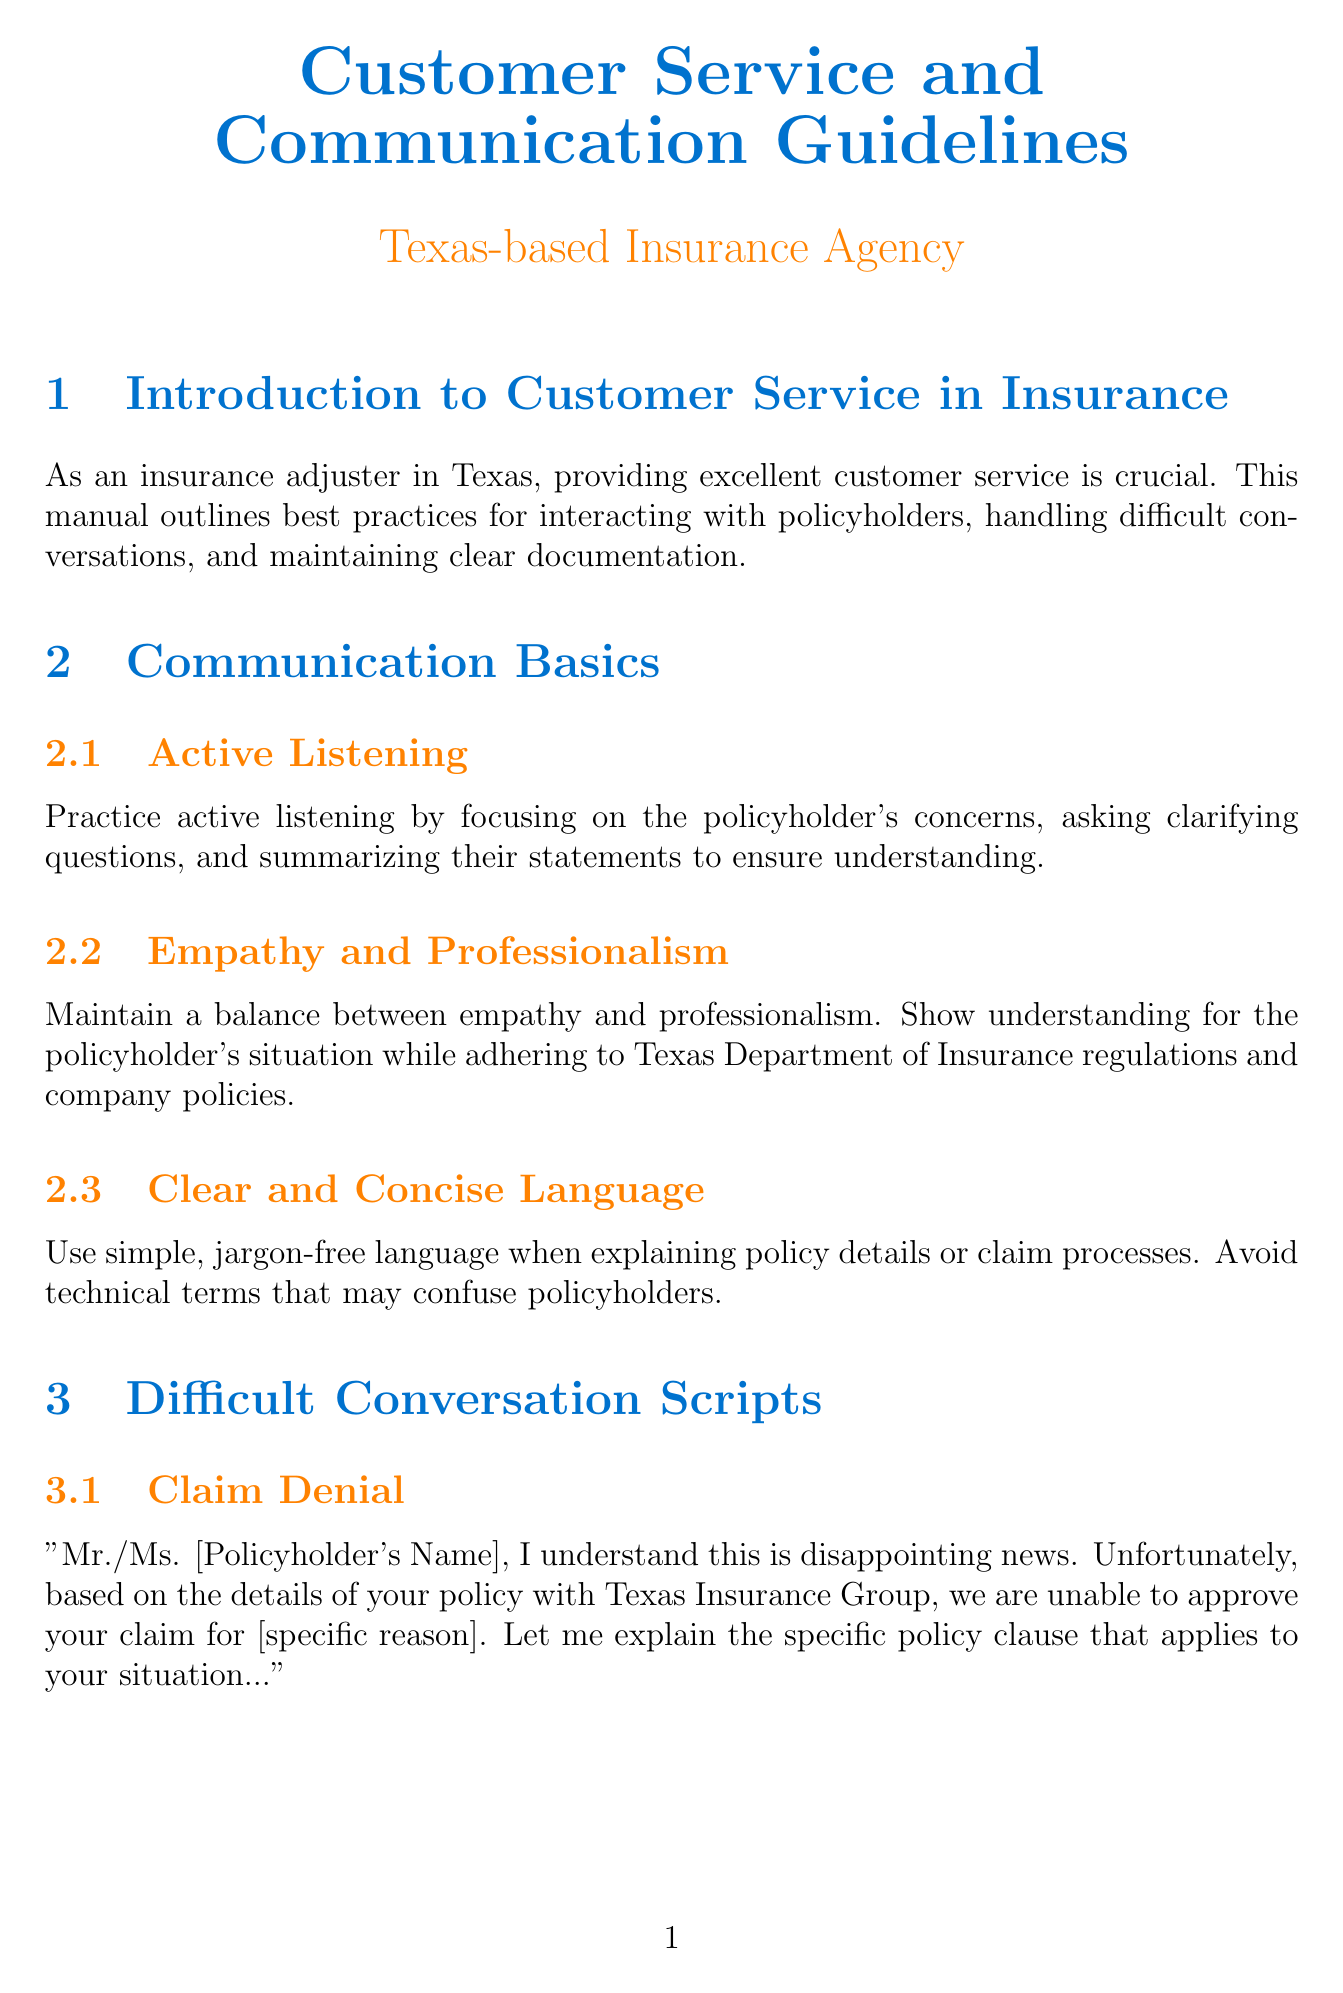what is the title of the manual? The title of the manual is presented at the beginning of the document.
Answer: Customer Service and Communication Guidelines how many sections are in the manual? The number of sections can be counted from the document outline.
Answer: 7 what does the script for Claim Denial begin with? The script provides a structured response that begins with a specific phrase to address the policyholder.
Answer: Mr./Ms. [Policyholder's Name], I understand this is disappointing news what is the purpose of Active Listening? The purpose is described in the subsection about communication basics.
Answer: Focusing on the policyholder's concerns what should be documented after each conversation? The guidelines outline what needs to be recorded.
Answer: All interactions with policyholders what is a specific case that requires empathy and professionalism? The document emphasizes a balance in a certain situation that may require empathy.
Answer: Handling policyholder's situation which organization provides flood insurance in the U.S.? The manual references a specific program for flood insurance.
Answer: National Flood Insurance Program what is crucial when documenting claims? The best practices section specifies an essential requirement for documentation.
Answer: Timely and Accurate Recording how should cultural differences be addressed according to the manual? The cultural sensitivity section outlines an approach for interaction with diverse populations.
Answer: Offer materials in Spanish 